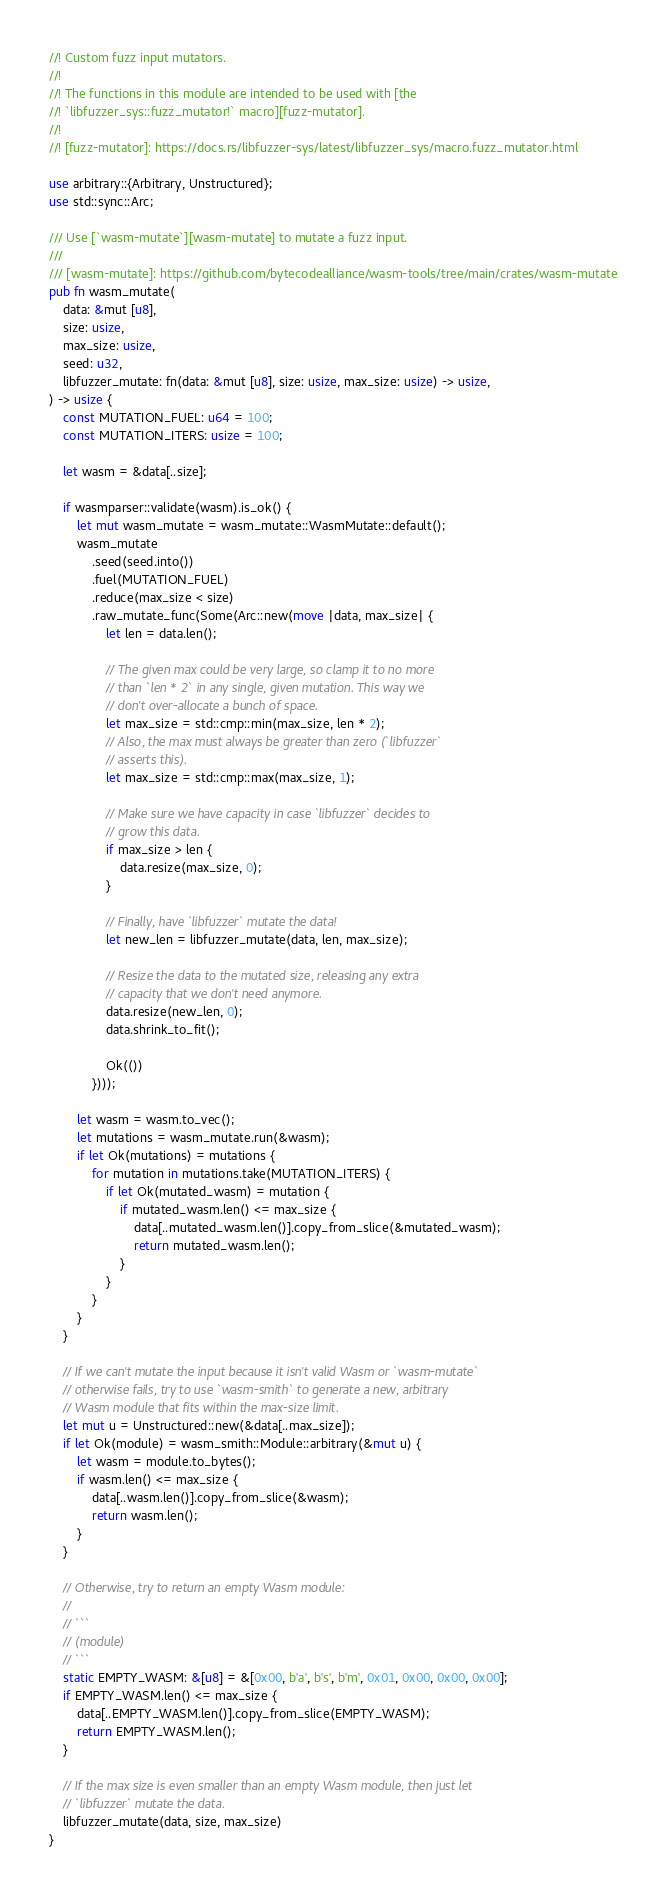<code> <loc_0><loc_0><loc_500><loc_500><_Rust_>//! Custom fuzz input mutators.
//!
//! The functions in this module are intended to be used with [the
//! `libfuzzer_sys::fuzz_mutator!` macro][fuzz-mutator].
//!
//! [fuzz-mutator]: https://docs.rs/libfuzzer-sys/latest/libfuzzer_sys/macro.fuzz_mutator.html

use arbitrary::{Arbitrary, Unstructured};
use std::sync::Arc;

/// Use [`wasm-mutate`][wasm-mutate] to mutate a fuzz input.
///
/// [wasm-mutate]: https://github.com/bytecodealliance/wasm-tools/tree/main/crates/wasm-mutate
pub fn wasm_mutate(
    data: &mut [u8],
    size: usize,
    max_size: usize,
    seed: u32,
    libfuzzer_mutate: fn(data: &mut [u8], size: usize, max_size: usize) -> usize,
) -> usize {
    const MUTATION_FUEL: u64 = 100;
    const MUTATION_ITERS: usize = 100;

    let wasm = &data[..size];

    if wasmparser::validate(wasm).is_ok() {
        let mut wasm_mutate = wasm_mutate::WasmMutate::default();
        wasm_mutate
            .seed(seed.into())
            .fuel(MUTATION_FUEL)
            .reduce(max_size < size)
            .raw_mutate_func(Some(Arc::new(move |data, max_size| {
                let len = data.len();

                // The given max could be very large, so clamp it to no more
                // than `len * 2` in any single, given mutation. This way we
                // don't over-allocate a bunch of space.
                let max_size = std::cmp::min(max_size, len * 2);
                // Also, the max must always be greater than zero (`libfuzzer`
                // asserts this).
                let max_size = std::cmp::max(max_size, 1);

                // Make sure we have capacity in case `libfuzzer` decides to
                // grow this data.
                if max_size > len {
                    data.resize(max_size, 0);
                }

                // Finally, have `libfuzzer` mutate the data!
                let new_len = libfuzzer_mutate(data, len, max_size);

                // Resize the data to the mutated size, releasing any extra
                // capacity that we don't need anymore.
                data.resize(new_len, 0);
                data.shrink_to_fit();

                Ok(())
            })));

        let wasm = wasm.to_vec();
        let mutations = wasm_mutate.run(&wasm);
        if let Ok(mutations) = mutations {
            for mutation in mutations.take(MUTATION_ITERS) {
                if let Ok(mutated_wasm) = mutation {
                    if mutated_wasm.len() <= max_size {
                        data[..mutated_wasm.len()].copy_from_slice(&mutated_wasm);
                        return mutated_wasm.len();
                    }
                }
            }
        }
    }

    // If we can't mutate the input because it isn't valid Wasm or `wasm-mutate`
    // otherwise fails, try to use `wasm-smith` to generate a new, arbitrary
    // Wasm module that fits within the max-size limit.
    let mut u = Unstructured::new(&data[..max_size]);
    if let Ok(module) = wasm_smith::Module::arbitrary(&mut u) {
        let wasm = module.to_bytes();
        if wasm.len() <= max_size {
            data[..wasm.len()].copy_from_slice(&wasm);
            return wasm.len();
        }
    }

    // Otherwise, try to return an empty Wasm module:
    //
    // ```
    // (module)
    // ```
    static EMPTY_WASM: &[u8] = &[0x00, b'a', b's', b'm', 0x01, 0x00, 0x00, 0x00];
    if EMPTY_WASM.len() <= max_size {
        data[..EMPTY_WASM.len()].copy_from_slice(EMPTY_WASM);
        return EMPTY_WASM.len();
    }

    // If the max size is even smaller than an empty Wasm module, then just let
    // `libfuzzer` mutate the data.
    libfuzzer_mutate(data, size, max_size)
}
</code> 